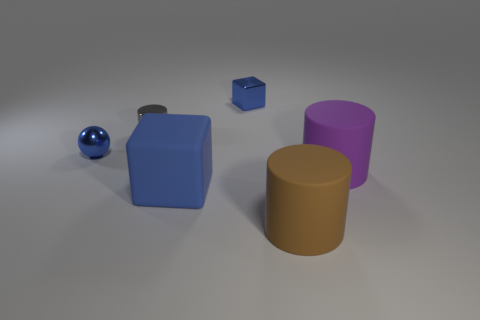Add 3 blue spheres. How many objects exist? 9 Subtract all cubes. How many objects are left? 4 Subtract all blue rubber cylinders. Subtract all tiny metallic cylinders. How many objects are left? 5 Add 2 large brown rubber cylinders. How many large brown rubber cylinders are left? 3 Add 1 small cyan objects. How many small cyan objects exist? 1 Subtract 0 purple cubes. How many objects are left? 6 